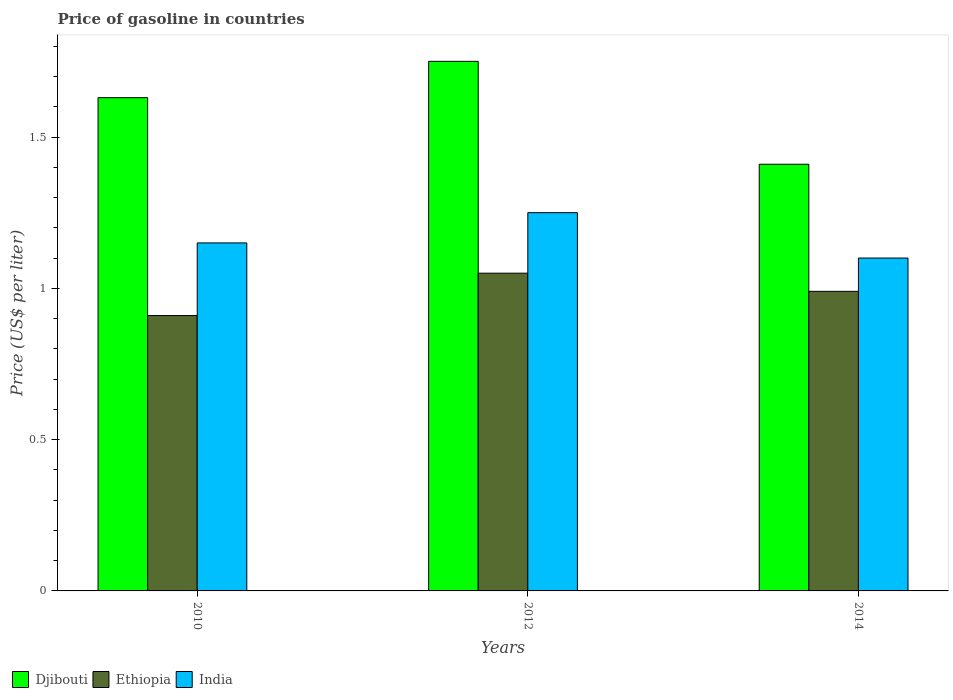How many groups of bars are there?
Keep it short and to the point. 3. How many bars are there on the 1st tick from the right?
Make the answer very short. 3. In how many cases, is the number of bars for a given year not equal to the number of legend labels?
Make the answer very short. 0. What is the price of gasoline in Ethiopia in 2014?
Offer a terse response. 0.99. Across all years, what is the minimum price of gasoline in Djibouti?
Ensure brevity in your answer.  1.41. In which year was the price of gasoline in India maximum?
Your answer should be compact. 2012. In which year was the price of gasoline in Djibouti minimum?
Give a very brief answer. 2014. What is the total price of gasoline in India in the graph?
Give a very brief answer. 3.5. What is the difference between the price of gasoline in Ethiopia in 2012 and that in 2014?
Ensure brevity in your answer.  0.06. What is the difference between the price of gasoline in Ethiopia in 2010 and the price of gasoline in India in 2014?
Offer a very short reply. -0.19. What is the average price of gasoline in Djibouti per year?
Your response must be concise. 1.6. In the year 2014, what is the difference between the price of gasoline in Ethiopia and price of gasoline in Djibouti?
Provide a succinct answer. -0.42. In how many years, is the price of gasoline in India greater than 0.9 US$?
Your answer should be compact. 3. What is the ratio of the price of gasoline in Djibouti in 2010 to that in 2012?
Provide a succinct answer. 0.93. Is the price of gasoline in Djibouti in 2010 less than that in 2014?
Keep it short and to the point. No. Is the difference between the price of gasoline in Ethiopia in 2010 and 2012 greater than the difference between the price of gasoline in Djibouti in 2010 and 2012?
Your answer should be compact. No. What is the difference between the highest and the second highest price of gasoline in Djibouti?
Make the answer very short. 0.12. What is the difference between the highest and the lowest price of gasoline in India?
Keep it short and to the point. 0.15. What does the 3rd bar from the left in 2014 represents?
Give a very brief answer. India. What does the 2nd bar from the right in 2014 represents?
Your answer should be very brief. Ethiopia. How many bars are there?
Provide a succinct answer. 9. Are all the bars in the graph horizontal?
Offer a very short reply. No. How many years are there in the graph?
Offer a terse response. 3. Are the values on the major ticks of Y-axis written in scientific E-notation?
Give a very brief answer. No. How many legend labels are there?
Keep it short and to the point. 3. How are the legend labels stacked?
Provide a short and direct response. Horizontal. What is the title of the graph?
Provide a succinct answer. Price of gasoline in countries. Does "Serbia" appear as one of the legend labels in the graph?
Offer a very short reply. No. What is the label or title of the X-axis?
Your response must be concise. Years. What is the label or title of the Y-axis?
Provide a short and direct response. Price (US$ per liter). What is the Price (US$ per liter) of Djibouti in 2010?
Make the answer very short. 1.63. What is the Price (US$ per liter) in Ethiopia in 2010?
Give a very brief answer. 0.91. What is the Price (US$ per liter) of India in 2010?
Offer a very short reply. 1.15. What is the Price (US$ per liter) of Ethiopia in 2012?
Give a very brief answer. 1.05. What is the Price (US$ per liter) in India in 2012?
Make the answer very short. 1.25. What is the Price (US$ per liter) in Djibouti in 2014?
Make the answer very short. 1.41. What is the Price (US$ per liter) of Ethiopia in 2014?
Provide a succinct answer. 0.99. Across all years, what is the maximum Price (US$ per liter) of Djibouti?
Give a very brief answer. 1.75. Across all years, what is the maximum Price (US$ per liter) of Ethiopia?
Keep it short and to the point. 1.05. Across all years, what is the minimum Price (US$ per liter) of Djibouti?
Your answer should be very brief. 1.41. Across all years, what is the minimum Price (US$ per liter) of Ethiopia?
Your answer should be very brief. 0.91. Across all years, what is the minimum Price (US$ per liter) of India?
Ensure brevity in your answer.  1.1. What is the total Price (US$ per liter) of Djibouti in the graph?
Offer a terse response. 4.79. What is the total Price (US$ per liter) in Ethiopia in the graph?
Your response must be concise. 2.95. What is the difference between the Price (US$ per liter) of Djibouti in 2010 and that in 2012?
Keep it short and to the point. -0.12. What is the difference between the Price (US$ per liter) in Ethiopia in 2010 and that in 2012?
Ensure brevity in your answer.  -0.14. What is the difference between the Price (US$ per liter) of Djibouti in 2010 and that in 2014?
Offer a terse response. 0.22. What is the difference between the Price (US$ per liter) of Ethiopia in 2010 and that in 2014?
Ensure brevity in your answer.  -0.08. What is the difference between the Price (US$ per liter) of India in 2010 and that in 2014?
Offer a terse response. 0.05. What is the difference between the Price (US$ per liter) in Djibouti in 2012 and that in 2014?
Your response must be concise. 0.34. What is the difference between the Price (US$ per liter) of Djibouti in 2010 and the Price (US$ per liter) of Ethiopia in 2012?
Provide a short and direct response. 0.58. What is the difference between the Price (US$ per liter) of Djibouti in 2010 and the Price (US$ per liter) of India in 2012?
Provide a succinct answer. 0.38. What is the difference between the Price (US$ per liter) in Ethiopia in 2010 and the Price (US$ per liter) in India in 2012?
Provide a succinct answer. -0.34. What is the difference between the Price (US$ per liter) of Djibouti in 2010 and the Price (US$ per liter) of Ethiopia in 2014?
Ensure brevity in your answer.  0.64. What is the difference between the Price (US$ per liter) of Djibouti in 2010 and the Price (US$ per liter) of India in 2014?
Make the answer very short. 0.53. What is the difference between the Price (US$ per liter) of Ethiopia in 2010 and the Price (US$ per liter) of India in 2014?
Offer a very short reply. -0.19. What is the difference between the Price (US$ per liter) in Djibouti in 2012 and the Price (US$ per liter) in Ethiopia in 2014?
Keep it short and to the point. 0.76. What is the difference between the Price (US$ per liter) of Djibouti in 2012 and the Price (US$ per liter) of India in 2014?
Offer a terse response. 0.65. What is the difference between the Price (US$ per liter) of Ethiopia in 2012 and the Price (US$ per liter) of India in 2014?
Offer a very short reply. -0.05. What is the average Price (US$ per liter) in Djibouti per year?
Give a very brief answer. 1.6. What is the average Price (US$ per liter) in Ethiopia per year?
Your response must be concise. 0.98. In the year 2010, what is the difference between the Price (US$ per liter) in Djibouti and Price (US$ per liter) in Ethiopia?
Give a very brief answer. 0.72. In the year 2010, what is the difference between the Price (US$ per liter) in Djibouti and Price (US$ per liter) in India?
Give a very brief answer. 0.48. In the year 2010, what is the difference between the Price (US$ per liter) of Ethiopia and Price (US$ per liter) of India?
Your answer should be compact. -0.24. In the year 2012, what is the difference between the Price (US$ per liter) in Djibouti and Price (US$ per liter) in Ethiopia?
Offer a terse response. 0.7. In the year 2012, what is the difference between the Price (US$ per liter) of Djibouti and Price (US$ per liter) of India?
Provide a succinct answer. 0.5. In the year 2014, what is the difference between the Price (US$ per liter) of Djibouti and Price (US$ per liter) of Ethiopia?
Ensure brevity in your answer.  0.42. In the year 2014, what is the difference between the Price (US$ per liter) of Djibouti and Price (US$ per liter) of India?
Make the answer very short. 0.31. In the year 2014, what is the difference between the Price (US$ per liter) in Ethiopia and Price (US$ per liter) in India?
Offer a terse response. -0.11. What is the ratio of the Price (US$ per liter) in Djibouti in 2010 to that in 2012?
Keep it short and to the point. 0.93. What is the ratio of the Price (US$ per liter) of Ethiopia in 2010 to that in 2012?
Provide a succinct answer. 0.87. What is the ratio of the Price (US$ per liter) in Djibouti in 2010 to that in 2014?
Provide a short and direct response. 1.16. What is the ratio of the Price (US$ per liter) of Ethiopia in 2010 to that in 2014?
Offer a very short reply. 0.92. What is the ratio of the Price (US$ per liter) of India in 2010 to that in 2014?
Make the answer very short. 1.05. What is the ratio of the Price (US$ per liter) in Djibouti in 2012 to that in 2014?
Offer a very short reply. 1.24. What is the ratio of the Price (US$ per liter) in Ethiopia in 2012 to that in 2014?
Give a very brief answer. 1.06. What is the ratio of the Price (US$ per liter) of India in 2012 to that in 2014?
Keep it short and to the point. 1.14. What is the difference between the highest and the second highest Price (US$ per liter) of Djibouti?
Your answer should be very brief. 0.12. What is the difference between the highest and the second highest Price (US$ per liter) of Ethiopia?
Provide a short and direct response. 0.06. What is the difference between the highest and the second highest Price (US$ per liter) of India?
Your answer should be very brief. 0.1. What is the difference between the highest and the lowest Price (US$ per liter) in Djibouti?
Your answer should be compact. 0.34. What is the difference between the highest and the lowest Price (US$ per liter) of Ethiopia?
Your answer should be compact. 0.14. 